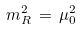Convert formula to latex. <formula><loc_0><loc_0><loc_500><loc_500>m ^ { 2 } _ { R } \, = \, \mu _ { 0 } ^ { 2 }</formula> 